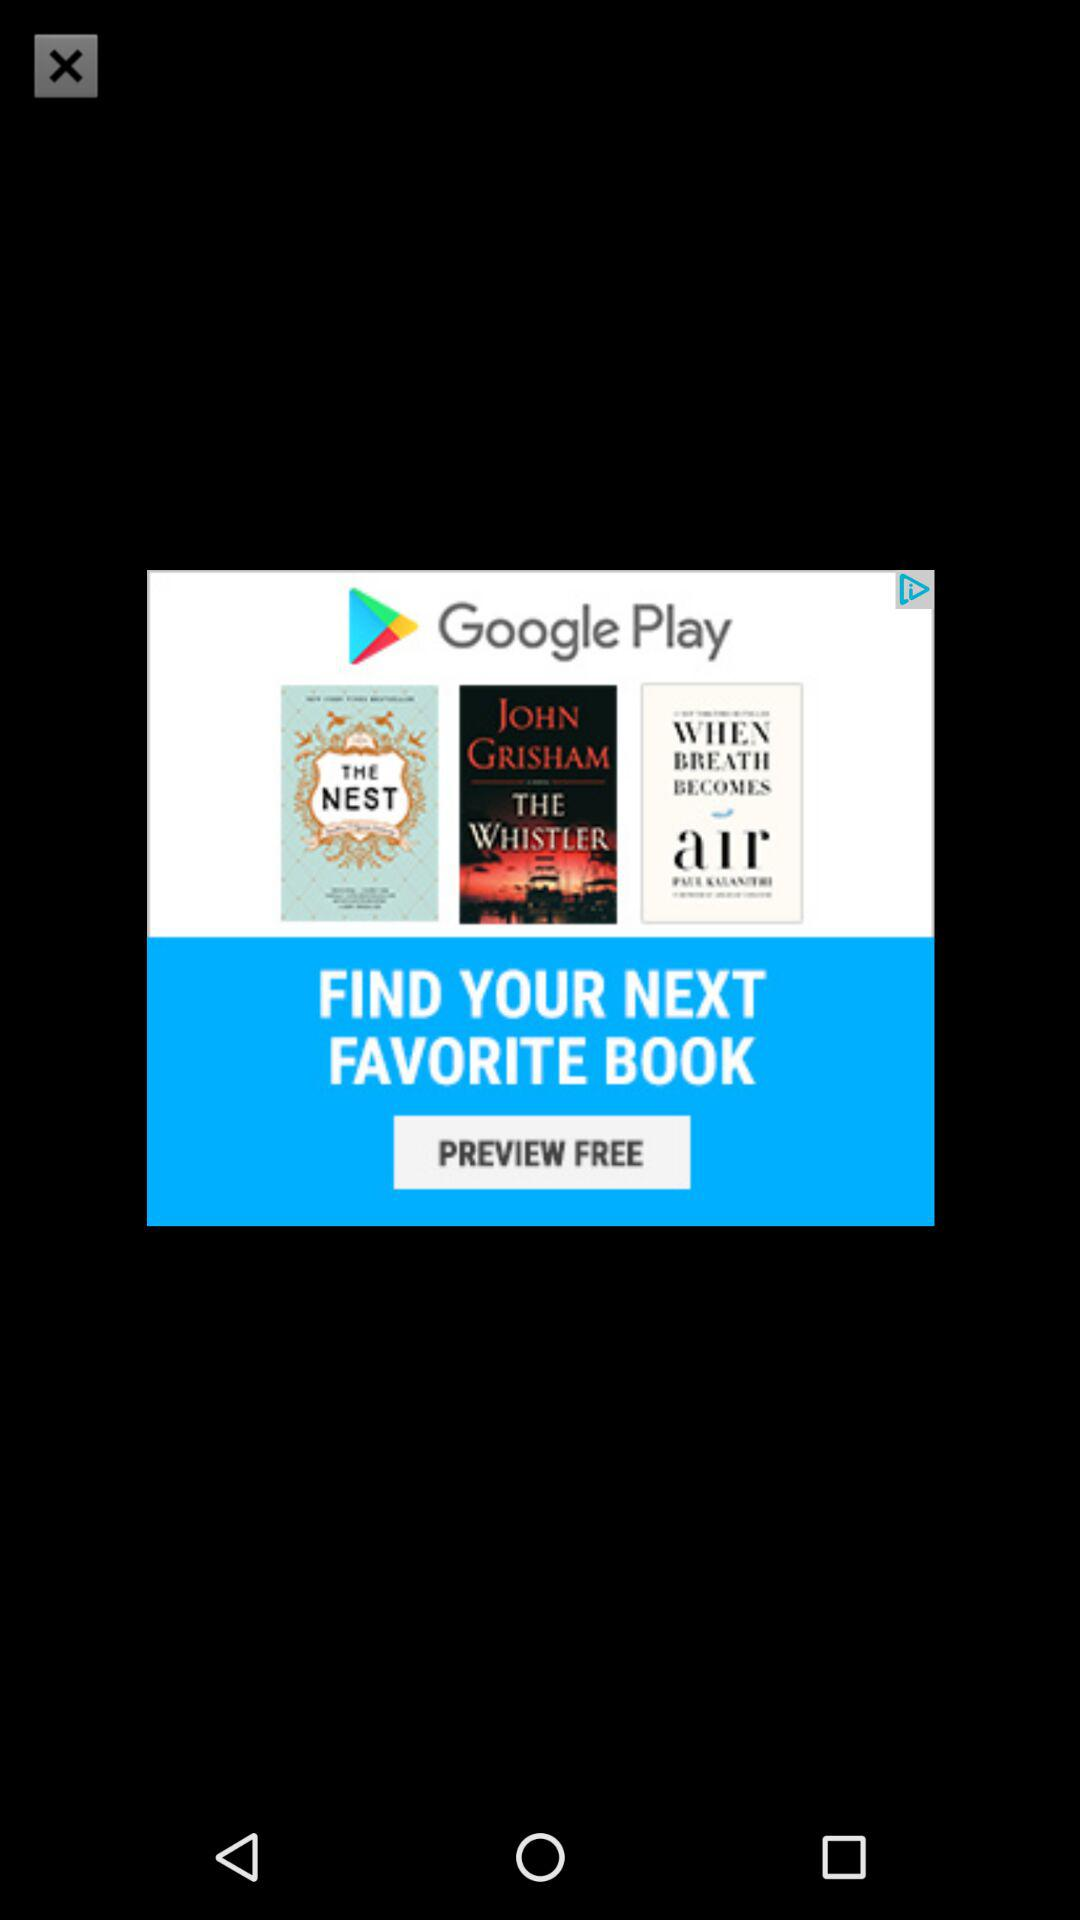How many books are featured in the Google Play ad?
Answer the question using a single word or phrase. 3 